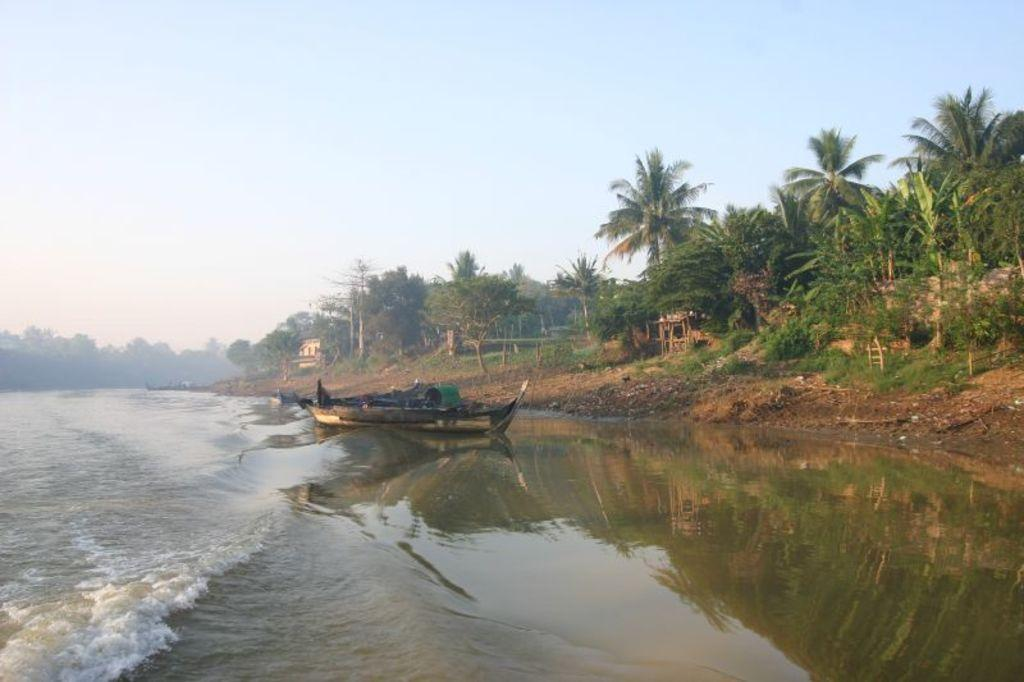What is on the water in the image? There are boats on the water in the image. What type of water body are the boats on? The water is part of a river. What can be seen in the background of the image? There are trees, plants, and grass on the ground in the background. What is visible in the sky in the image? There are clouds in the sky. How many books can be seen on the boats in the image? There are no books visible on the boats in the image. Is there a chicken on the grass in the background of the image? There is no chicken present in the image. 